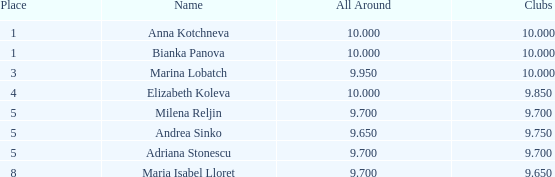How many locations are named bianka panova with fewer than 10 clubs? 0.0. 